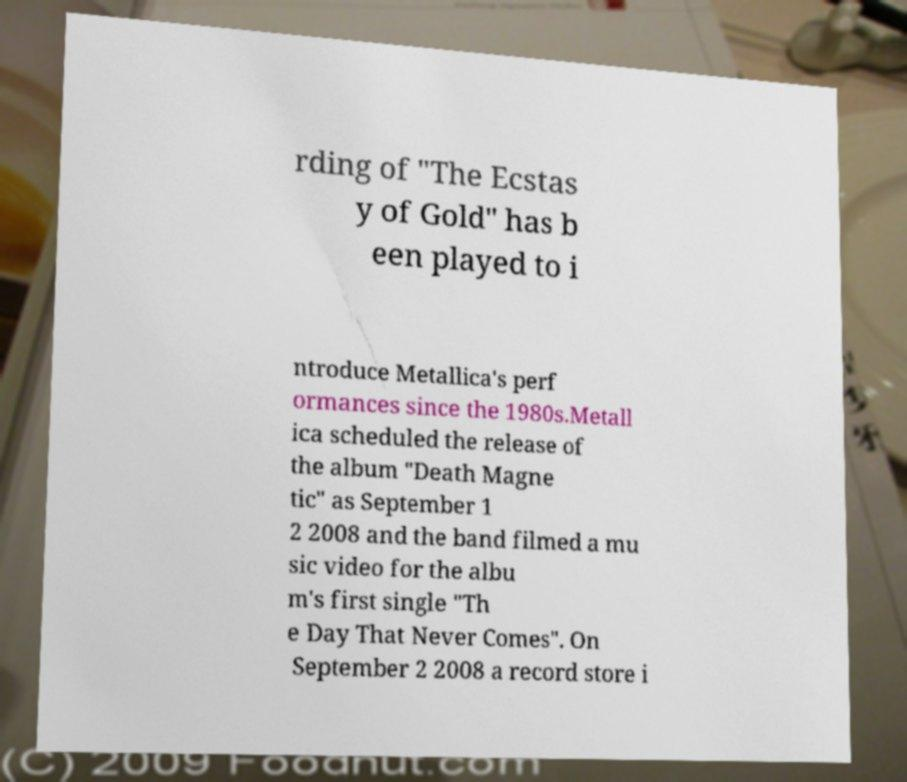Please identify and transcribe the text found in this image. rding of "The Ecstas y of Gold" has b een played to i ntroduce Metallica's perf ormances since the 1980s.Metall ica scheduled the release of the album "Death Magne tic" as September 1 2 2008 and the band filmed a mu sic video for the albu m's first single "Th e Day That Never Comes". On September 2 2008 a record store i 